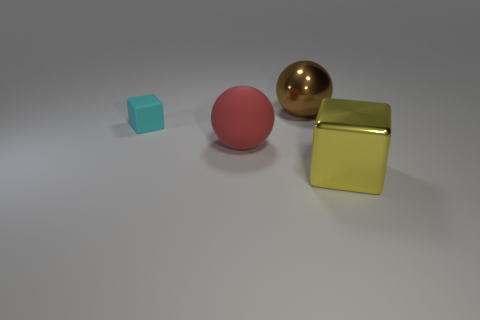There is a metallic object that is on the right side of the big brown thing; is it the same shape as the tiny cyan matte thing? Yes, the gold metallic object on the right side appears to be a sphere, which is the same shape as the smaller cyan matte object to its left. 